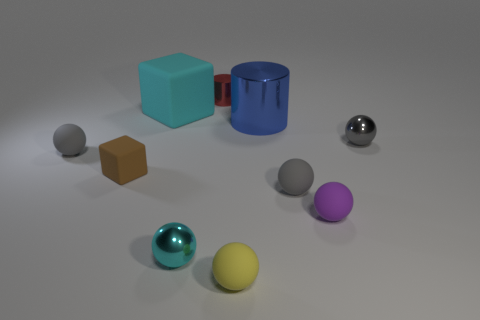Is there a tiny ball that is behind the tiny gray rubber ball in front of the small rubber ball that is left of the red thing?
Your answer should be very brief. Yes. Is the shape of the tiny shiny object that is to the left of the tiny red thing the same as the small thing that is to the right of the purple rubber ball?
Your answer should be compact. Yes. Is the number of gray rubber objects behind the small block greater than the number of tiny yellow cubes?
Your answer should be very brief. Yes. How many things are brown matte cubes or green blocks?
Give a very brief answer. 1. What is the color of the tiny rubber block?
Keep it short and to the point. Brown. What number of other things are the same color as the large rubber cube?
Your answer should be compact. 1. Are there any tiny matte objects behind the tiny yellow matte thing?
Ensure brevity in your answer.  Yes. There is a tiny rubber sphere to the left of the tiny metal ball in front of the gray rubber thing to the right of the cyan matte thing; what is its color?
Offer a very short reply. Gray. What number of tiny gray spheres are both on the right side of the red thing and left of the gray metallic ball?
Your response must be concise. 1. How many spheres are either tiny purple objects or gray metal things?
Offer a terse response. 2. 